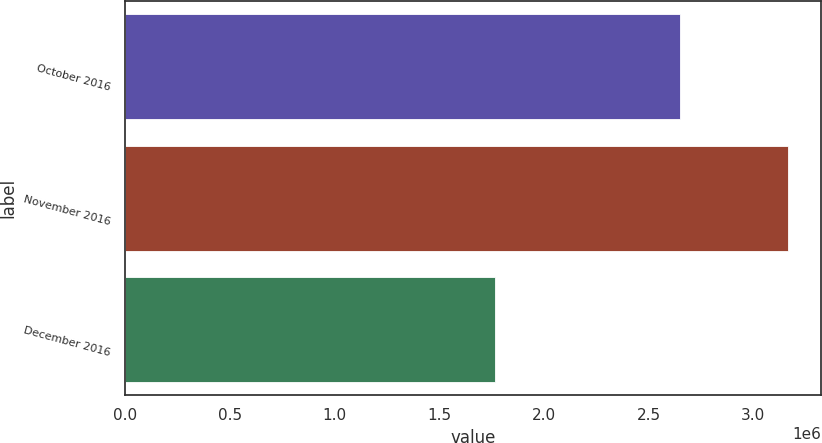Convert chart to OTSL. <chart><loc_0><loc_0><loc_500><loc_500><bar_chart><fcel>October 2016<fcel>November 2016<fcel>December 2016<nl><fcel>2.65063e+06<fcel>3.16401e+06<fcel>1.76862e+06<nl></chart> 